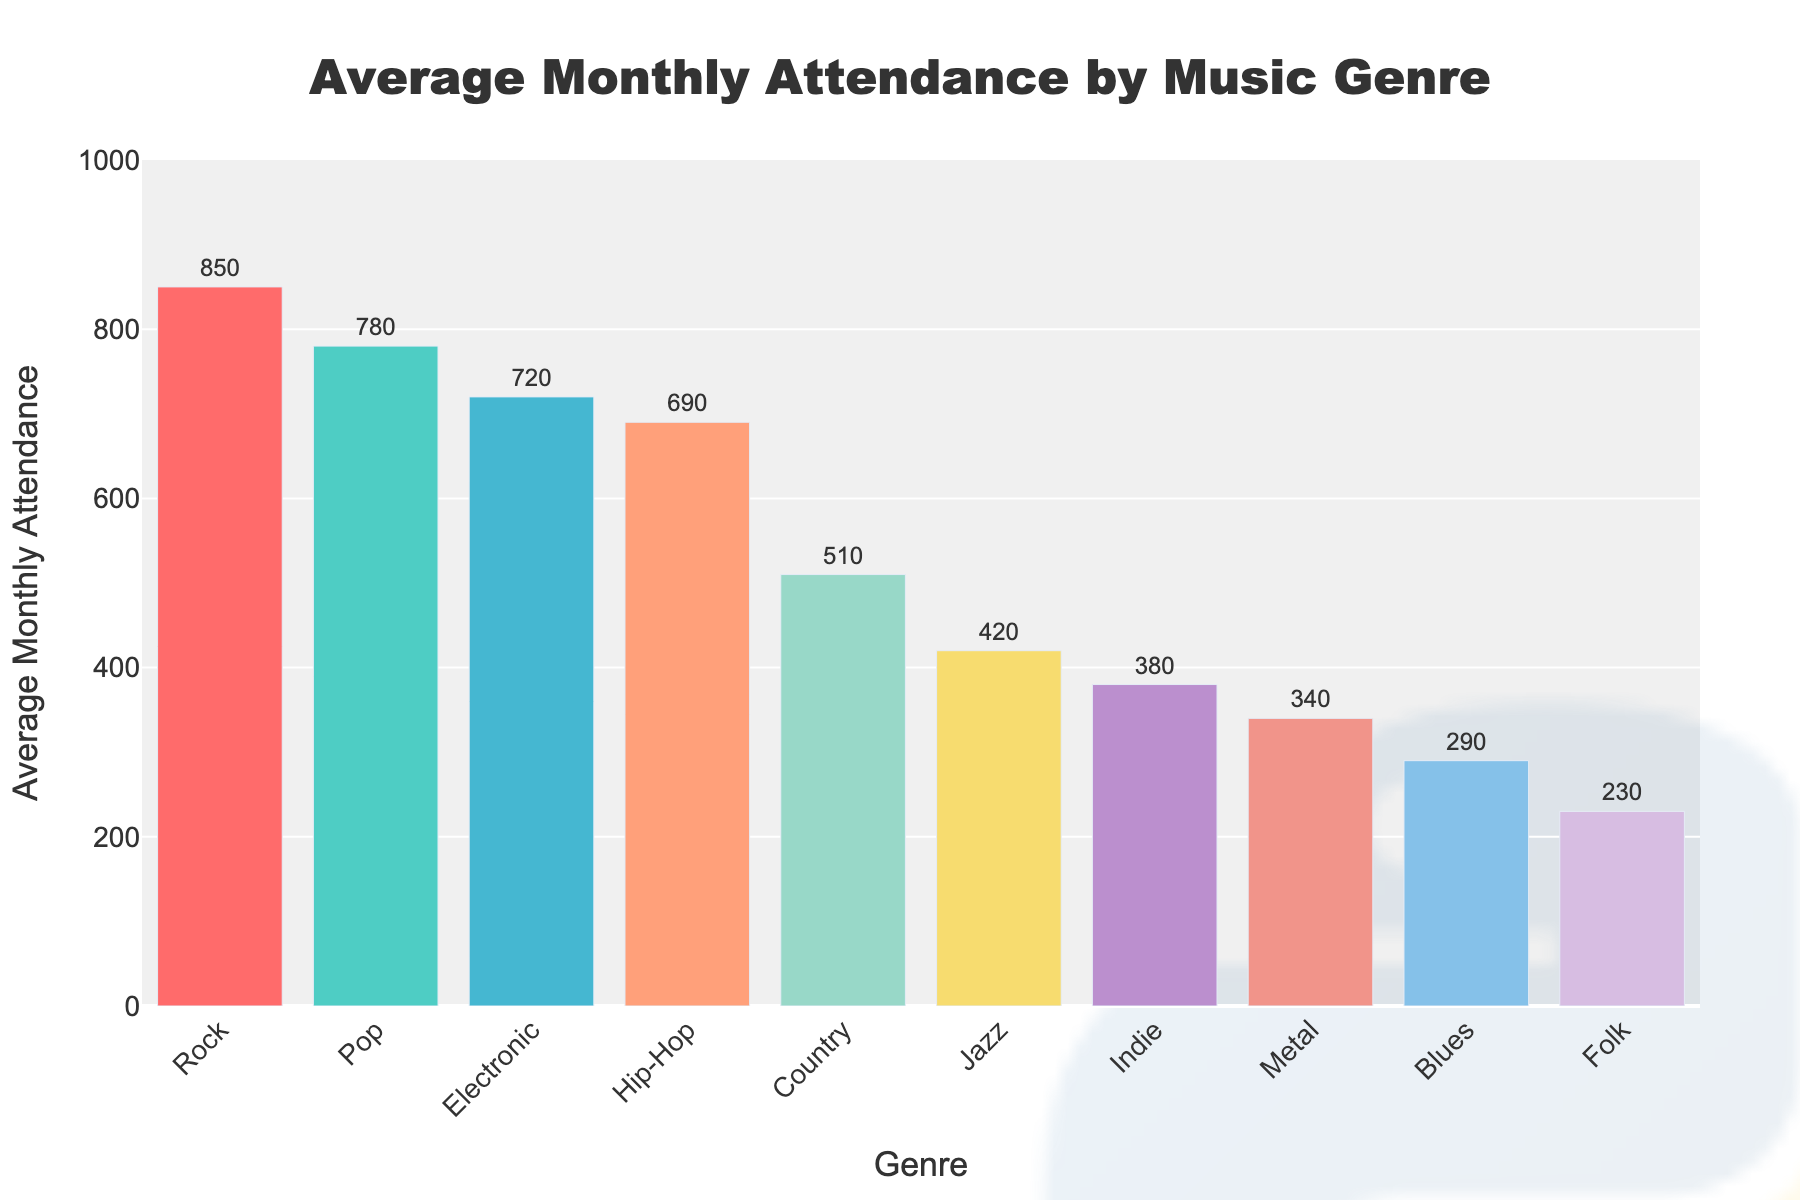which music genre has the highest average monthly attendance? The bar chart shows attendance for each genre. The tallest bar represents the genre with the highest attendance, which is Rock.
Answer: Rock Which music genre has the lowest average monthly attendance? The shortest bar represents the genre with the lowest attendance, which is Folk.
Answer: Folk By how much does the average attendance for Rock exceed the average attendance for Folk? The attendance for Rock is 850 and for Folk is 230. The difference is 850 - 230.
Answer: 620 What is the combined average monthly attendance for Pop, Hip-Hop, and Electronic? Sum the attendances: Pop (780) + Hip-Hop (690) + Electronic (720) = 2190.
Answer: 2190 How much more is the attendance for Pop than for Jazz? The attendance for Pop is 780 and for Jazz is 420. The difference is 780 - 420.
Answer: 360 rank the genres from highest to lowest average monthly attendance The chart already sorts the genres: Rock (850), Pop (780), Electronic (720), Hip-Hop (690), Country (510), Jazz (420), Indie (380), Metal (340), Blues (290), Folk (230).
Answer: Rock, Pop, Electronic, Hip-Hop, Country, Jazz, Indie, Metal, Blues, Folk What is the average attendance of the top three genres combined divided by the number of these genres? The top three genres are Rock, Pop, and Electronic. Their combined attendance is 850 + 780 + 720 = 2350. To find the average, divide this by 3.
Answer: 783.33 What is the difference in attendance between the genre with the second highest and the fourth highest average monthly attendance? The second highest attendance is Pop (780) and the fourth highest is Hip-Hop (690). The difference is 780 - 690.
Answer: 90 How does the attendance for Country compare to that of Metal? The attendance for Country is 510, and for Metal is 340. Country's attendance is higher.
Answer: Country's attendance is higher What color represents the Blues genre in the chart? The color for each genre can be identified by the color of the corresponding bar. The Blues genre is represented by a bar colored in a shade of red.
Answer: Red 